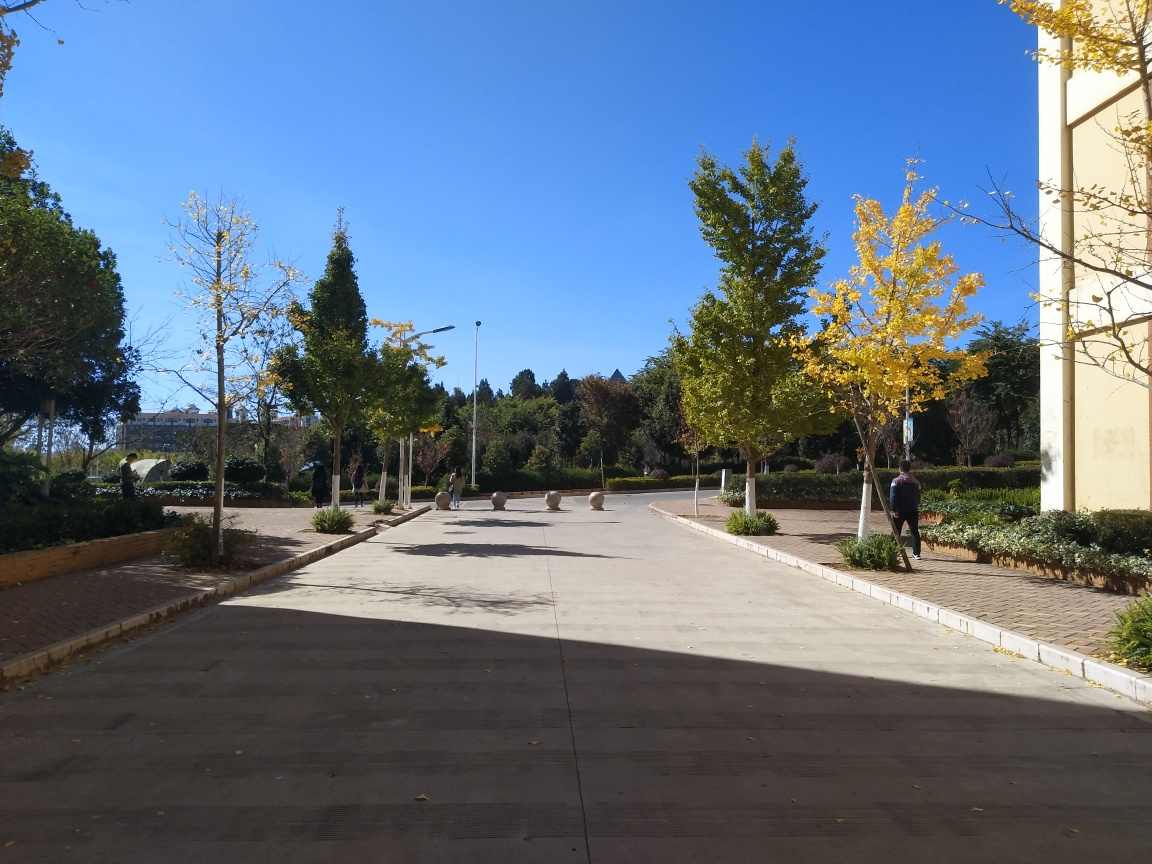Can you tell me more about the architecture style of the building in the background? The building in the distance appears to have classical influences, noted by its symmetrical structure and the presence of what seems to be pilasters or columns. While details are not fully clear due to the distance, the architecture suggests a formal and possibly institutional building. 